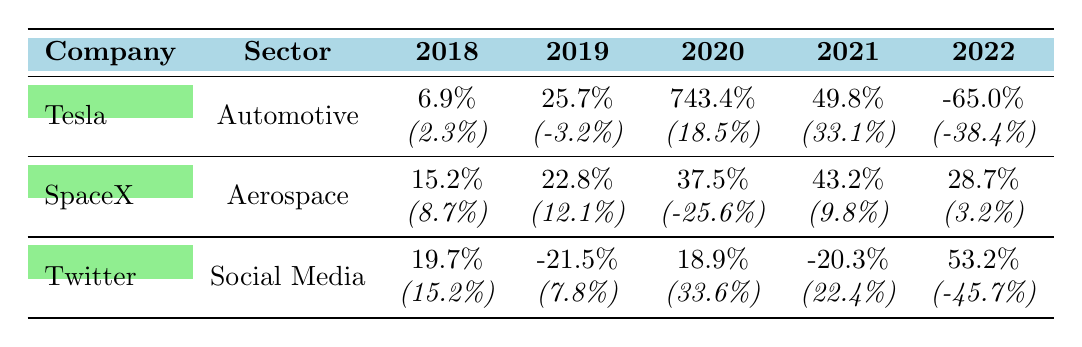What was Tesla's stock performance in 2020 compared to the automotive sector average? Tesla's growth in 2020 was 743.4%, while the automotive sector's average growth was 18.5%. This indicates that Tesla significantly outperformed the sector that year.
Answer: Tesla: 743.4%, Sector: 18.5% Did SpaceX have a positive growth every year from 2018 to 2022? Reviewing the data shows that SpaceX had positive growth in 2018, 2019, 2020, 2021, and 2022. Therefore, it did experience positive growth every year in that period.
Answer: Yes What is the overall trend for Twitter's stock performance over the years 2018 to 2022? By examining the table, Twitter had positive growth in 2018, negative growth in 2019, positive growth in 2020, negative growth in 2021, and positive growth in 2022. This shows a fluctuating trend with two highs and two lows.
Answer: Fluctuating trend What was the average company growth for Tesla from 2018 to 2022? To find the average growth, add Tesla's growth percentages for the five years: 6.9 + 25.7 + 743.4 + 49.8 - 65.0 = 760.8. Then divide by 5, resulting in an average of 152.16%.
Answer: 152.16% How many times did SpaceX outperform the aerospace sector average in 2019? In 2019, SpaceX's growth was 22.8%, while the aerospace sector's average was 12.1%. Since SpaceX's growth is greater than the sector average, it outperformed the sector that year.
Answer: Yes Which company experienced the largest decline in growth in 2022, relative to its previous year's performance? Analyzing the data for 2022, Tesla's growth dropped from 49.8% in 2021 to -65.0%, while other companies either maintained or had less negative growth. Thus, Tesla experienced the largest decline.
Answer: Tesla Did any of the companies have a higher growth percentage than their respective sector average in 2021? Checking the values for 2021, Tesla had 49.8% compared to 33.1%, SpaceX had 43.2% compared to 9.8%, and Twitter had -20.3% compared to 22.4%. Both Tesla and SpaceX had higher performance than their sector average that year.
Answer: Yes, Tesla and SpaceX What was the difference between Twitter’s company growth and the sector average in 2022? Twitter's growth in 2022 was 53.2%, while the sector average was -45.7%. The difference can be calculated as 53.2 - (-45.7) = 53.2 + 45.7 = 98.9%.
Answer: 98.9% 